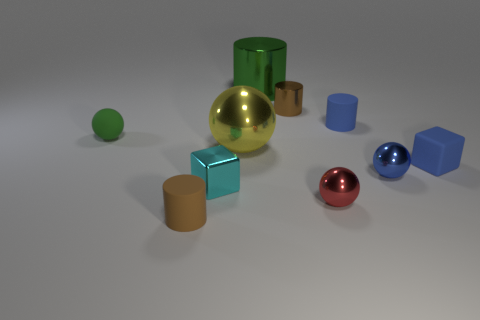Is the color of the matte cylinder that is left of the big green thing the same as the small metal cylinder?
Your response must be concise. Yes. Is there a matte thing that has the same color as the small metallic cylinder?
Offer a terse response. Yes. There is a tiny blue thing behind the sphere that is on the left side of the object in front of the small red metal object; what shape is it?
Make the answer very short. Cylinder. Is there another blue cube that has the same material as the blue block?
Your answer should be very brief. No. Is the color of the tiny rubber cylinder that is behind the blue cube the same as the small metallic ball that is behind the tiny cyan shiny thing?
Offer a terse response. Yes. Are there fewer cyan shiny blocks that are left of the small brown metal cylinder than small purple metal cylinders?
Give a very brief answer. No. What number of things are tiny cyan balls or small brown cylinders in front of the tiny blue block?
Offer a very short reply. 1. There is a sphere that is the same material as the blue cube; what color is it?
Your answer should be compact. Green. How many things are brown rubber things or big purple metal cubes?
Your response must be concise. 1. There is a metal cube that is the same size as the red metal thing; what color is it?
Your answer should be compact. Cyan. 